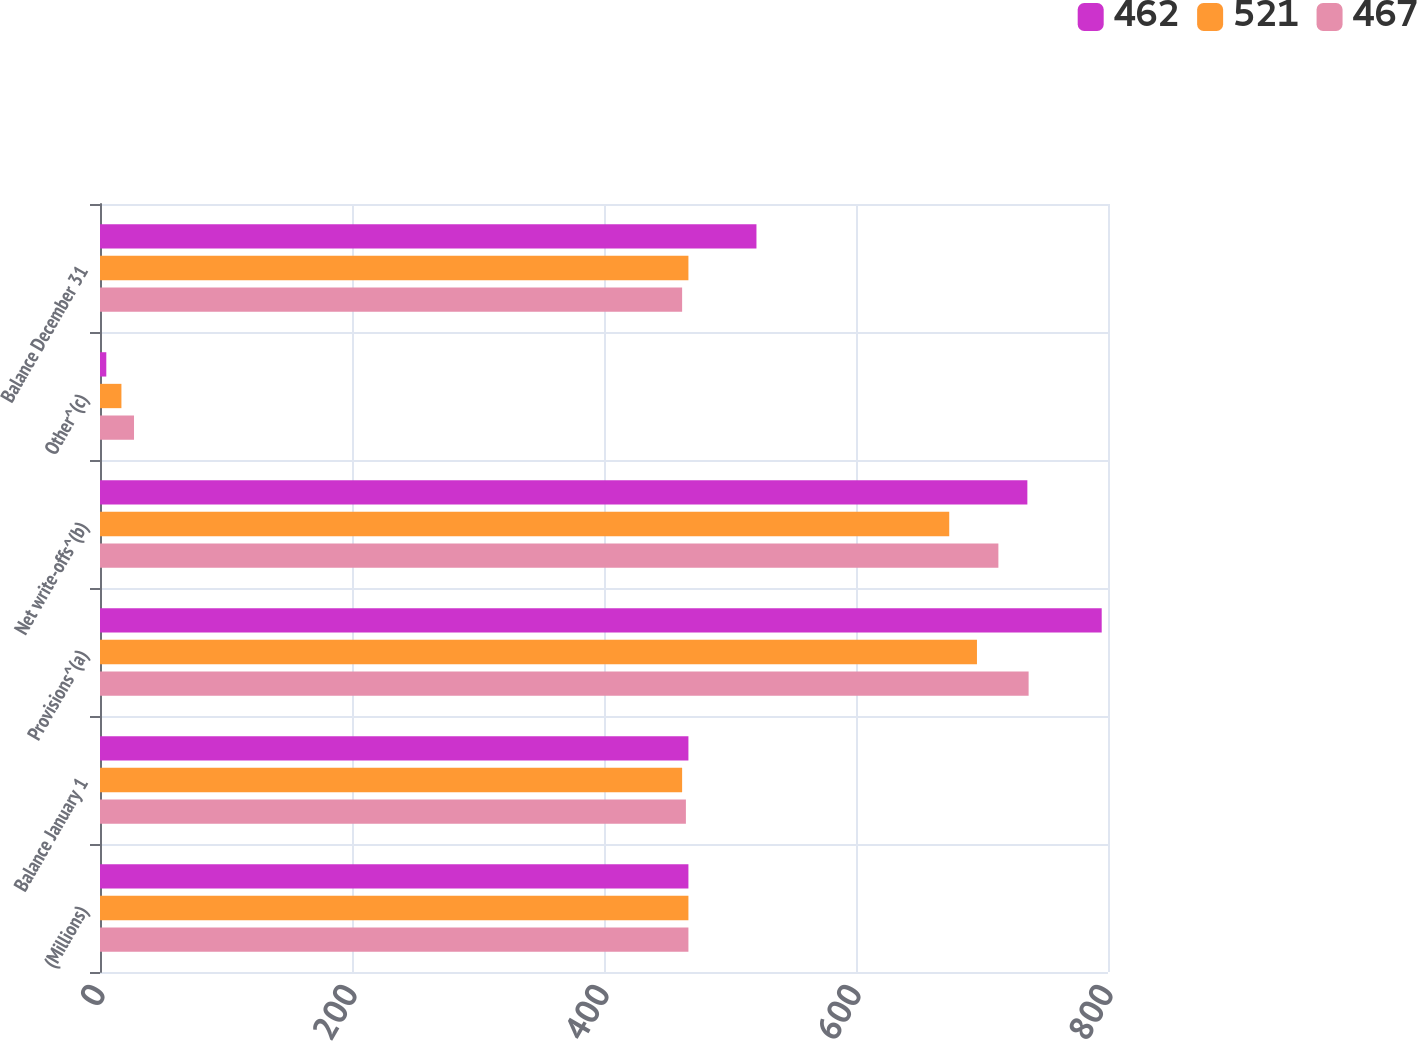Convert chart. <chart><loc_0><loc_0><loc_500><loc_500><stacked_bar_chart><ecel><fcel>(Millions)<fcel>Balance January 1<fcel>Provisions^(a)<fcel>Net write-offs^(b)<fcel>Other^(c)<fcel>Balance December 31<nl><fcel>462<fcel>467<fcel>467<fcel>795<fcel>736<fcel>5<fcel>521<nl><fcel>521<fcel>467<fcel>462<fcel>696<fcel>674<fcel>17<fcel>467<nl><fcel>467<fcel>467<fcel>465<fcel>737<fcel>713<fcel>27<fcel>462<nl></chart> 